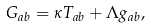Convert formula to latex. <formula><loc_0><loc_0><loc_500><loc_500>G _ { a b } = \kappa T _ { a b } + \Lambda g _ { a b } ,</formula> 